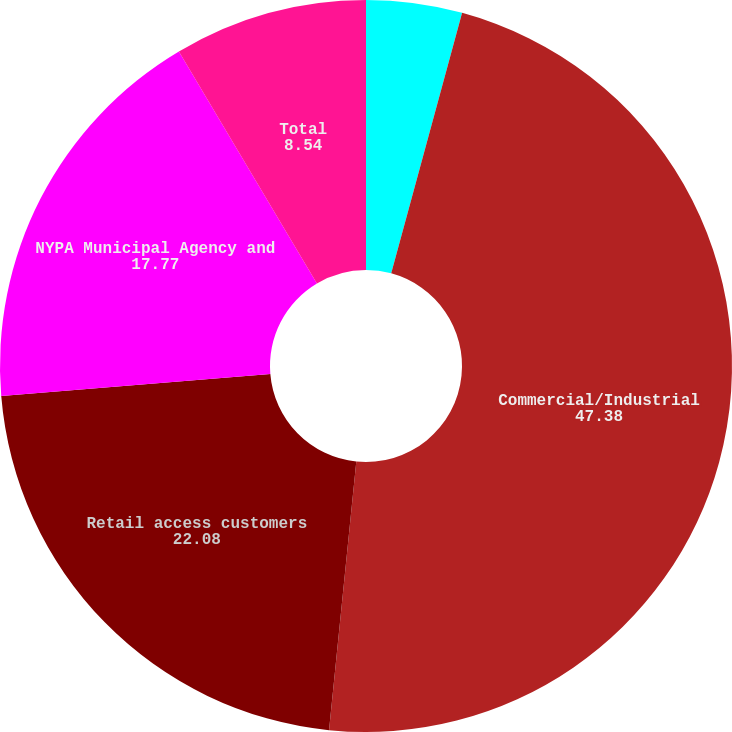Convert chart. <chart><loc_0><loc_0><loc_500><loc_500><pie_chart><fcel>Residential/Religious(a)<fcel>Commercial/Industrial<fcel>Retail access customers<fcel>NYPA Municipal Agency and<fcel>Total<nl><fcel>4.23%<fcel>47.38%<fcel>22.08%<fcel>17.77%<fcel>8.54%<nl></chart> 